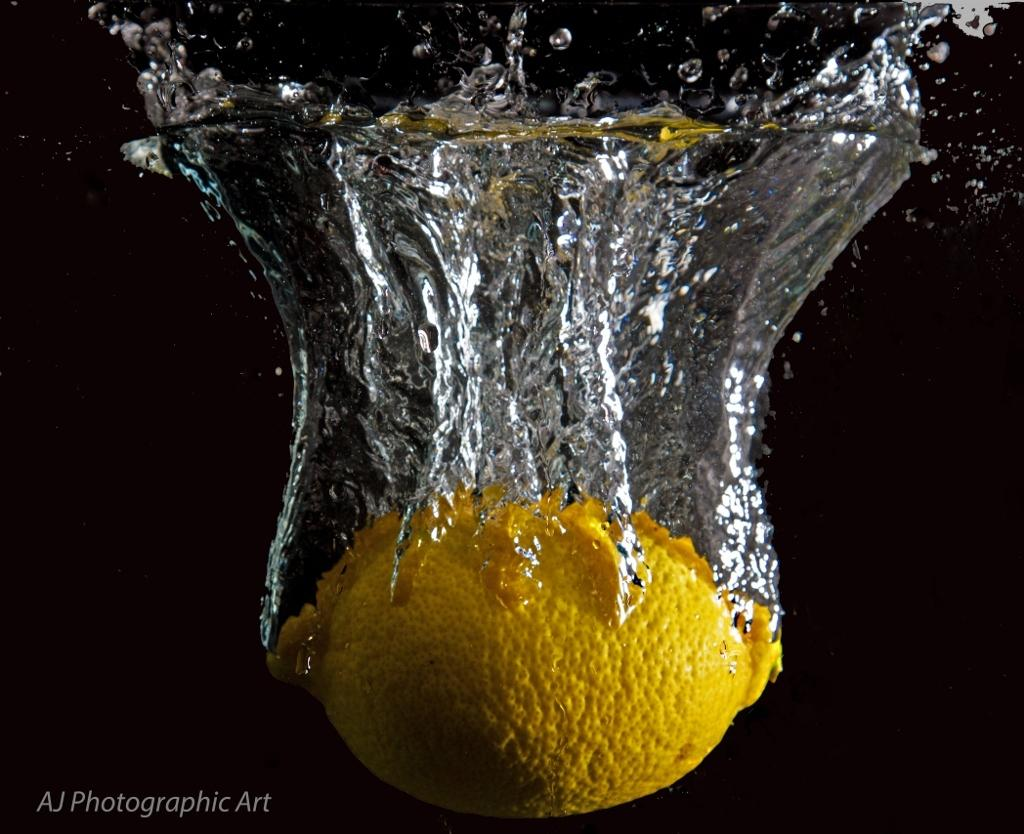What color is the object that is in the water in the image? The object is yellow. Can you describe the location of the yellow object in the image? The yellow object is in the water. What type of dress is the boy wearing in the image? There is no boy or dress present in the image; it only features a yellow object in the water. 